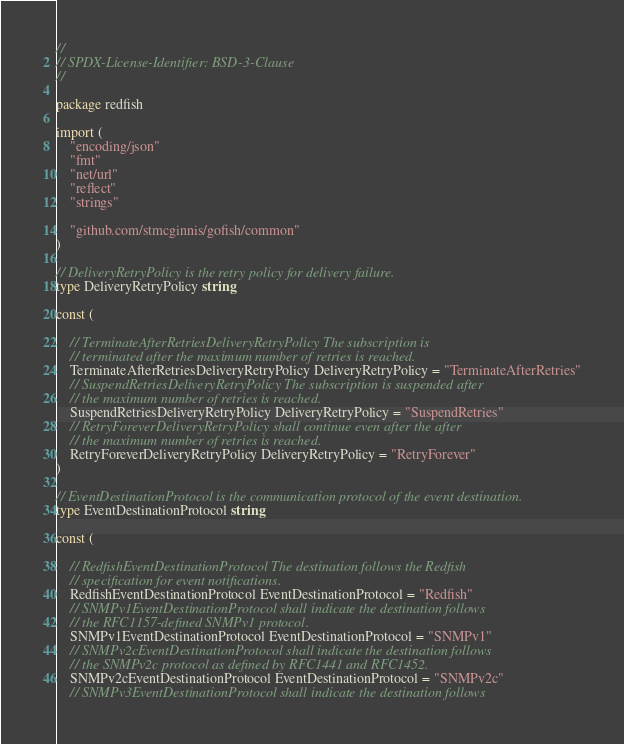<code> <loc_0><loc_0><loc_500><loc_500><_Go_>//
// SPDX-License-Identifier: BSD-3-Clause
//

package redfish

import (
	"encoding/json"
	"fmt"
	"net/url"
	"reflect"
	"strings"

	"github.com/stmcginnis/gofish/common"
)

// DeliveryRetryPolicy is the retry policy for delivery failure.
type DeliveryRetryPolicy string

const (

	// TerminateAfterRetriesDeliveryRetryPolicy The subscription is
	// terminated after the maximum number of retries is reached.
	TerminateAfterRetriesDeliveryRetryPolicy DeliveryRetryPolicy = "TerminateAfterRetries"
	// SuspendRetriesDeliveryRetryPolicy The subscription is suspended after
	// the maximum number of retries is reached.
	SuspendRetriesDeliveryRetryPolicy DeliveryRetryPolicy = "SuspendRetries"
	// RetryForeverDeliveryRetryPolicy shall continue even after the after
	// the maximum number of retries is reached.
	RetryForeverDeliveryRetryPolicy DeliveryRetryPolicy = "RetryForever"
)

// EventDestinationProtocol is the communication protocol of the event destination.
type EventDestinationProtocol string

const (

	// RedfishEventDestinationProtocol The destination follows the Redfish
	// specification for event notifications.
	RedfishEventDestinationProtocol EventDestinationProtocol = "Redfish"
	// SNMPv1EventDestinationProtocol shall indicate the destination follows
	// the RFC1157-defined SNMPv1 protocol.
	SNMPv1EventDestinationProtocol EventDestinationProtocol = "SNMPv1"
	// SNMPv2cEventDestinationProtocol shall indicate the destination follows
	// the SNMPv2c protocol as defined by RFC1441 and RFC1452.
	SNMPv2cEventDestinationProtocol EventDestinationProtocol = "SNMPv2c"
	// SNMPv3EventDestinationProtocol shall indicate the destination follows</code> 